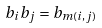Convert formula to latex. <formula><loc_0><loc_0><loc_500><loc_500>b _ { i } b _ { j } = b _ { m ( i , j ) }</formula> 